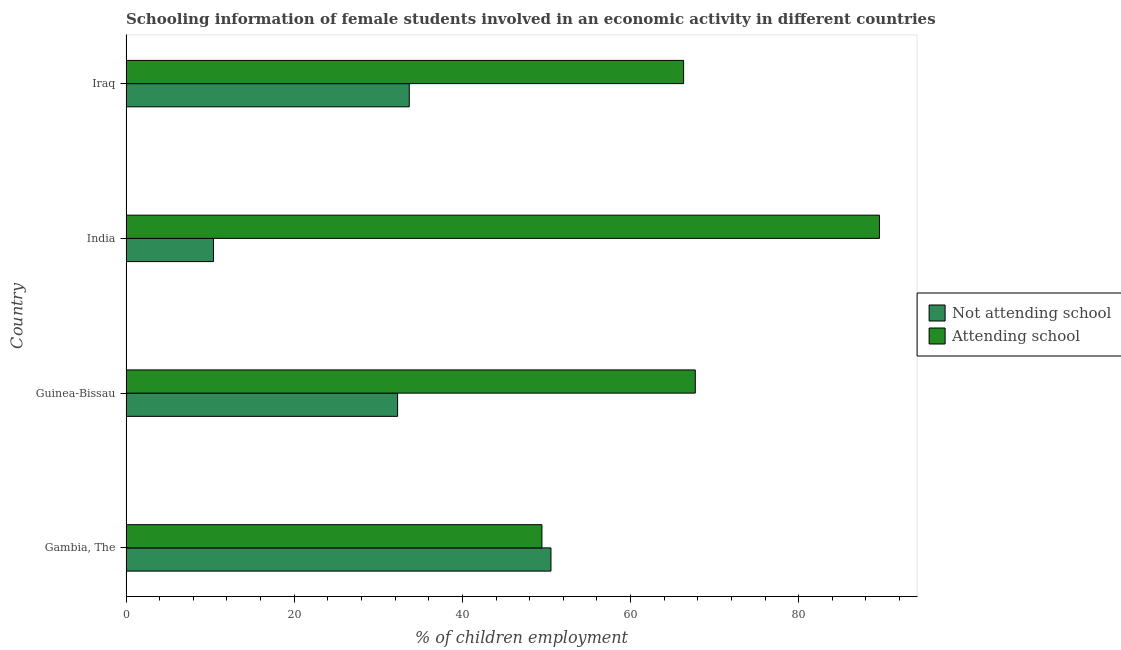Are the number of bars on each tick of the Y-axis equal?
Provide a succinct answer. Yes. How many bars are there on the 4th tick from the top?
Your response must be concise. 2. How many bars are there on the 1st tick from the bottom?
Provide a short and direct response. 2. What is the label of the 3rd group of bars from the top?
Your answer should be compact. Guinea-Bissau. In how many cases, is the number of bars for a given country not equal to the number of legend labels?
Make the answer very short. 0. What is the percentage of employed females who are not attending school in Gambia, The?
Ensure brevity in your answer.  50.54. Across all countries, what is the maximum percentage of employed females who are attending school?
Your answer should be compact. 89.6. In which country was the percentage of employed females who are not attending school maximum?
Your response must be concise. Gambia, The. In which country was the percentage of employed females who are attending school minimum?
Give a very brief answer. Gambia, The. What is the total percentage of employed females who are attending school in the graph?
Offer a very short reply. 273.08. What is the difference between the percentage of employed females who are attending school in Guinea-Bissau and that in India?
Ensure brevity in your answer.  -21.9. What is the difference between the percentage of employed females who are not attending school in Iraq and the percentage of employed females who are attending school in Guinea-Bissau?
Provide a succinct answer. -34.01. What is the average percentage of employed females who are not attending school per country?
Your response must be concise. 31.73. What is the difference between the percentage of employed females who are attending school and percentage of employed females who are not attending school in India?
Make the answer very short. 79.2. In how many countries, is the percentage of employed females who are not attending school greater than 72 %?
Make the answer very short. 0. What is the ratio of the percentage of employed females who are not attending school in Gambia, The to that in Guinea-Bissau?
Provide a succinct answer. 1.56. What is the difference between the highest and the second highest percentage of employed females who are attending school?
Provide a succinct answer. 21.9. What is the difference between the highest and the lowest percentage of employed females who are attending school?
Offer a terse response. 40.14. In how many countries, is the percentage of employed females who are not attending school greater than the average percentage of employed females who are not attending school taken over all countries?
Offer a very short reply. 3. Is the sum of the percentage of employed females who are not attending school in Guinea-Bissau and Iraq greater than the maximum percentage of employed females who are attending school across all countries?
Offer a terse response. No. What does the 2nd bar from the top in Gambia, The represents?
Your answer should be very brief. Not attending school. What does the 1st bar from the bottom in Gambia, The represents?
Offer a very short reply. Not attending school. How many countries are there in the graph?
Give a very brief answer. 4. What is the difference between two consecutive major ticks on the X-axis?
Offer a terse response. 20. Does the graph contain any zero values?
Your response must be concise. No. Does the graph contain grids?
Your answer should be compact. No. Where does the legend appear in the graph?
Provide a succinct answer. Center right. How many legend labels are there?
Give a very brief answer. 2. What is the title of the graph?
Ensure brevity in your answer.  Schooling information of female students involved in an economic activity in different countries. Does "Central government" appear as one of the legend labels in the graph?
Offer a terse response. No. What is the label or title of the X-axis?
Ensure brevity in your answer.  % of children employment. What is the % of children employment in Not attending school in Gambia, The?
Your response must be concise. 50.54. What is the % of children employment of Attending school in Gambia, The?
Make the answer very short. 49.46. What is the % of children employment of Not attending school in Guinea-Bissau?
Your answer should be compact. 32.3. What is the % of children employment in Attending school in Guinea-Bissau?
Provide a succinct answer. 67.7. What is the % of children employment in Not attending school in India?
Make the answer very short. 10.4. What is the % of children employment in Attending school in India?
Give a very brief answer. 89.6. What is the % of children employment of Not attending school in Iraq?
Give a very brief answer. 33.69. What is the % of children employment of Attending school in Iraq?
Give a very brief answer. 66.31. Across all countries, what is the maximum % of children employment in Not attending school?
Give a very brief answer. 50.54. Across all countries, what is the maximum % of children employment in Attending school?
Give a very brief answer. 89.6. Across all countries, what is the minimum % of children employment of Not attending school?
Provide a short and direct response. 10.4. Across all countries, what is the minimum % of children employment of Attending school?
Provide a succinct answer. 49.46. What is the total % of children employment in Not attending school in the graph?
Ensure brevity in your answer.  126.92. What is the total % of children employment of Attending school in the graph?
Make the answer very short. 273.08. What is the difference between the % of children employment in Not attending school in Gambia, The and that in Guinea-Bissau?
Give a very brief answer. 18.24. What is the difference between the % of children employment of Attending school in Gambia, The and that in Guinea-Bissau?
Your answer should be compact. -18.24. What is the difference between the % of children employment in Not attending school in Gambia, The and that in India?
Your response must be concise. 40.14. What is the difference between the % of children employment of Attending school in Gambia, The and that in India?
Your response must be concise. -40.14. What is the difference between the % of children employment of Not attending school in Gambia, The and that in Iraq?
Ensure brevity in your answer.  16.85. What is the difference between the % of children employment in Attending school in Gambia, The and that in Iraq?
Provide a succinct answer. -16.85. What is the difference between the % of children employment of Not attending school in Guinea-Bissau and that in India?
Provide a short and direct response. 21.9. What is the difference between the % of children employment in Attending school in Guinea-Bissau and that in India?
Ensure brevity in your answer.  -21.9. What is the difference between the % of children employment of Not attending school in Guinea-Bissau and that in Iraq?
Ensure brevity in your answer.  -1.39. What is the difference between the % of children employment in Attending school in Guinea-Bissau and that in Iraq?
Give a very brief answer. 1.39. What is the difference between the % of children employment of Not attending school in India and that in Iraq?
Your answer should be very brief. -23.29. What is the difference between the % of children employment of Attending school in India and that in Iraq?
Provide a succinct answer. 23.29. What is the difference between the % of children employment in Not attending school in Gambia, The and the % of children employment in Attending school in Guinea-Bissau?
Make the answer very short. -17.16. What is the difference between the % of children employment in Not attending school in Gambia, The and the % of children employment in Attending school in India?
Your answer should be compact. -39.06. What is the difference between the % of children employment in Not attending school in Gambia, The and the % of children employment in Attending school in Iraq?
Give a very brief answer. -15.78. What is the difference between the % of children employment in Not attending school in Guinea-Bissau and the % of children employment in Attending school in India?
Offer a very short reply. -57.3. What is the difference between the % of children employment in Not attending school in Guinea-Bissau and the % of children employment in Attending school in Iraq?
Make the answer very short. -34.01. What is the difference between the % of children employment of Not attending school in India and the % of children employment of Attending school in Iraq?
Provide a succinct answer. -55.91. What is the average % of children employment in Not attending school per country?
Give a very brief answer. 31.73. What is the average % of children employment in Attending school per country?
Ensure brevity in your answer.  68.27. What is the difference between the % of children employment of Not attending school and % of children employment of Attending school in Gambia, The?
Provide a short and direct response. 1.07. What is the difference between the % of children employment in Not attending school and % of children employment in Attending school in Guinea-Bissau?
Keep it short and to the point. -35.4. What is the difference between the % of children employment of Not attending school and % of children employment of Attending school in India?
Offer a terse response. -79.2. What is the difference between the % of children employment of Not attending school and % of children employment of Attending school in Iraq?
Your answer should be very brief. -32.63. What is the ratio of the % of children employment in Not attending school in Gambia, The to that in Guinea-Bissau?
Your answer should be very brief. 1.56. What is the ratio of the % of children employment of Attending school in Gambia, The to that in Guinea-Bissau?
Provide a short and direct response. 0.73. What is the ratio of the % of children employment in Not attending school in Gambia, The to that in India?
Your answer should be very brief. 4.86. What is the ratio of the % of children employment in Attending school in Gambia, The to that in India?
Offer a very short reply. 0.55. What is the ratio of the % of children employment in Not attending school in Gambia, The to that in Iraq?
Offer a terse response. 1.5. What is the ratio of the % of children employment in Attending school in Gambia, The to that in Iraq?
Offer a terse response. 0.75. What is the ratio of the % of children employment in Not attending school in Guinea-Bissau to that in India?
Offer a terse response. 3.11. What is the ratio of the % of children employment of Attending school in Guinea-Bissau to that in India?
Offer a terse response. 0.76. What is the ratio of the % of children employment of Not attending school in Guinea-Bissau to that in Iraq?
Make the answer very short. 0.96. What is the ratio of the % of children employment in Attending school in Guinea-Bissau to that in Iraq?
Offer a very short reply. 1.02. What is the ratio of the % of children employment of Not attending school in India to that in Iraq?
Offer a very short reply. 0.31. What is the ratio of the % of children employment of Attending school in India to that in Iraq?
Give a very brief answer. 1.35. What is the difference between the highest and the second highest % of children employment of Not attending school?
Make the answer very short. 16.85. What is the difference between the highest and the second highest % of children employment of Attending school?
Make the answer very short. 21.9. What is the difference between the highest and the lowest % of children employment in Not attending school?
Keep it short and to the point. 40.14. What is the difference between the highest and the lowest % of children employment of Attending school?
Your response must be concise. 40.14. 